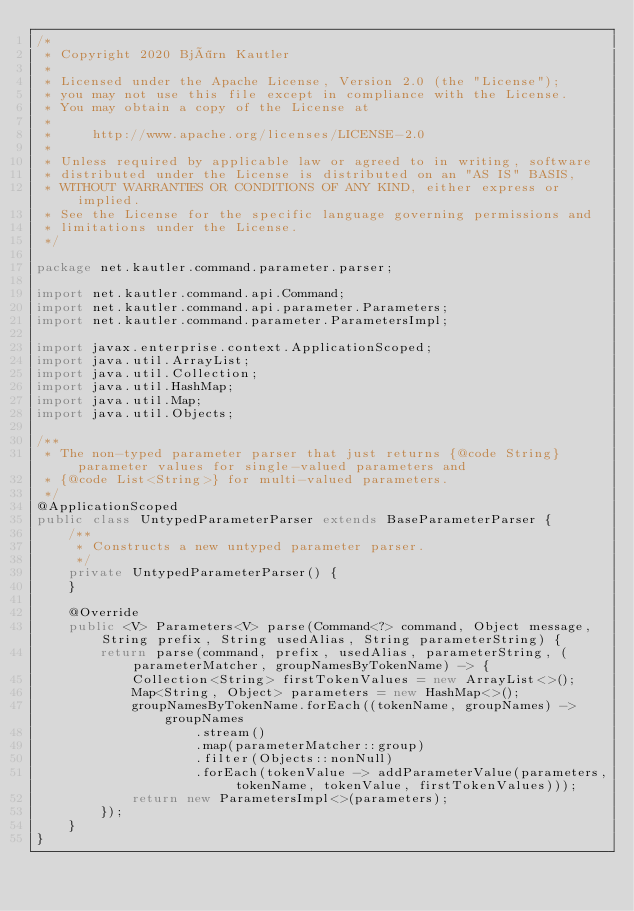Convert code to text. <code><loc_0><loc_0><loc_500><loc_500><_Java_>/*
 * Copyright 2020 Björn Kautler
 *
 * Licensed under the Apache License, Version 2.0 (the "License");
 * you may not use this file except in compliance with the License.
 * You may obtain a copy of the License at
 *
 *     http://www.apache.org/licenses/LICENSE-2.0
 *
 * Unless required by applicable law or agreed to in writing, software
 * distributed under the License is distributed on an "AS IS" BASIS,
 * WITHOUT WARRANTIES OR CONDITIONS OF ANY KIND, either express or implied.
 * See the License for the specific language governing permissions and
 * limitations under the License.
 */

package net.kautler.command.parameter.parser;

import net.kautler.command.api.Command;
import net.kautler.command.api.parameter.Parameters;
import net.kautler.command.parameter.ParametersImpl;

import javax.enterprise.context.ApplicationScoped;
import java.util.ArrayList;
import java.util.Collection;
import java.util.HashMap;
import java.util.Map;
import java.util.Objects;

/**
 * The non-typed parameter parser that just returns {@code String} parameter values for single-valued parameters and
 * {@code List<String>} for multi-valued parameters.
 */
@ApplicationScoped
public class UntypedParameterParser extends BaseParameterParser {
    /**
     * Constructs a new untyped parameter parser.
     */
    private UntypedParameterParser() {
    }

    @Override
    public <V> Parameters<V> parse(Command<?> command, Object message, String prefix, String usedAlias, String parameterString) {
        return parse(command, prefix, usedAlias, parameterString, (parameterMatcher, groupNamesByTokenName) -> {
            Collection<String> firstTokenValues = new ArrayList<>();
            Map<String, Object> parameters = new HashMap<>();
            groupNamesByTokenName.forEach((tokenName, groupNames) -> groupNames
                    .stream()
                    .map(parameterMatcher::group)
                    .filter(Objects::nonNull)
                    .forEach(tokenValue -> addParameterValue(parameters, tokenName, tokenValue, firstTokenValues)));
            return new ParametersImpl<>(parameters);
        });
    }
}
</code> 